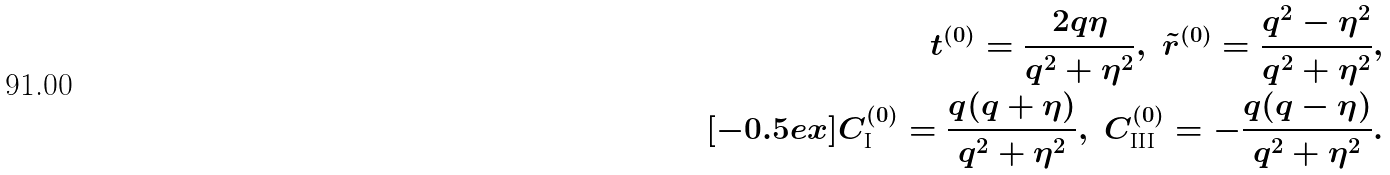Convert formula to latex. <formula><loc_0><loc_0><loc_500><loc_500>t ^ { ( 0 ) } = \frac { 2 q \eta } { q ^ { 2 } + \eta ^ { 2 } } , \ \tilde { r } ^ { ( 0 ) } = \frac { q ^ { 2 } - \eta ^ { 2 } } { q ^ { 2 } + \eta ^ { 2 } } , \\ [ - 0 . 5 e x ] C _ { \text {I} } ^ { ( 0 ) } = \frac { q ( q + \eta ) } { q ^ { 2 } + \eta ^ { 2 } } , \ C _ { \text {III} } ^ { ( 0 ) } = - \frac { q ( q - \eta ) } { q ^ { 2 } + \eta ^ { 2 } } .</formula> 